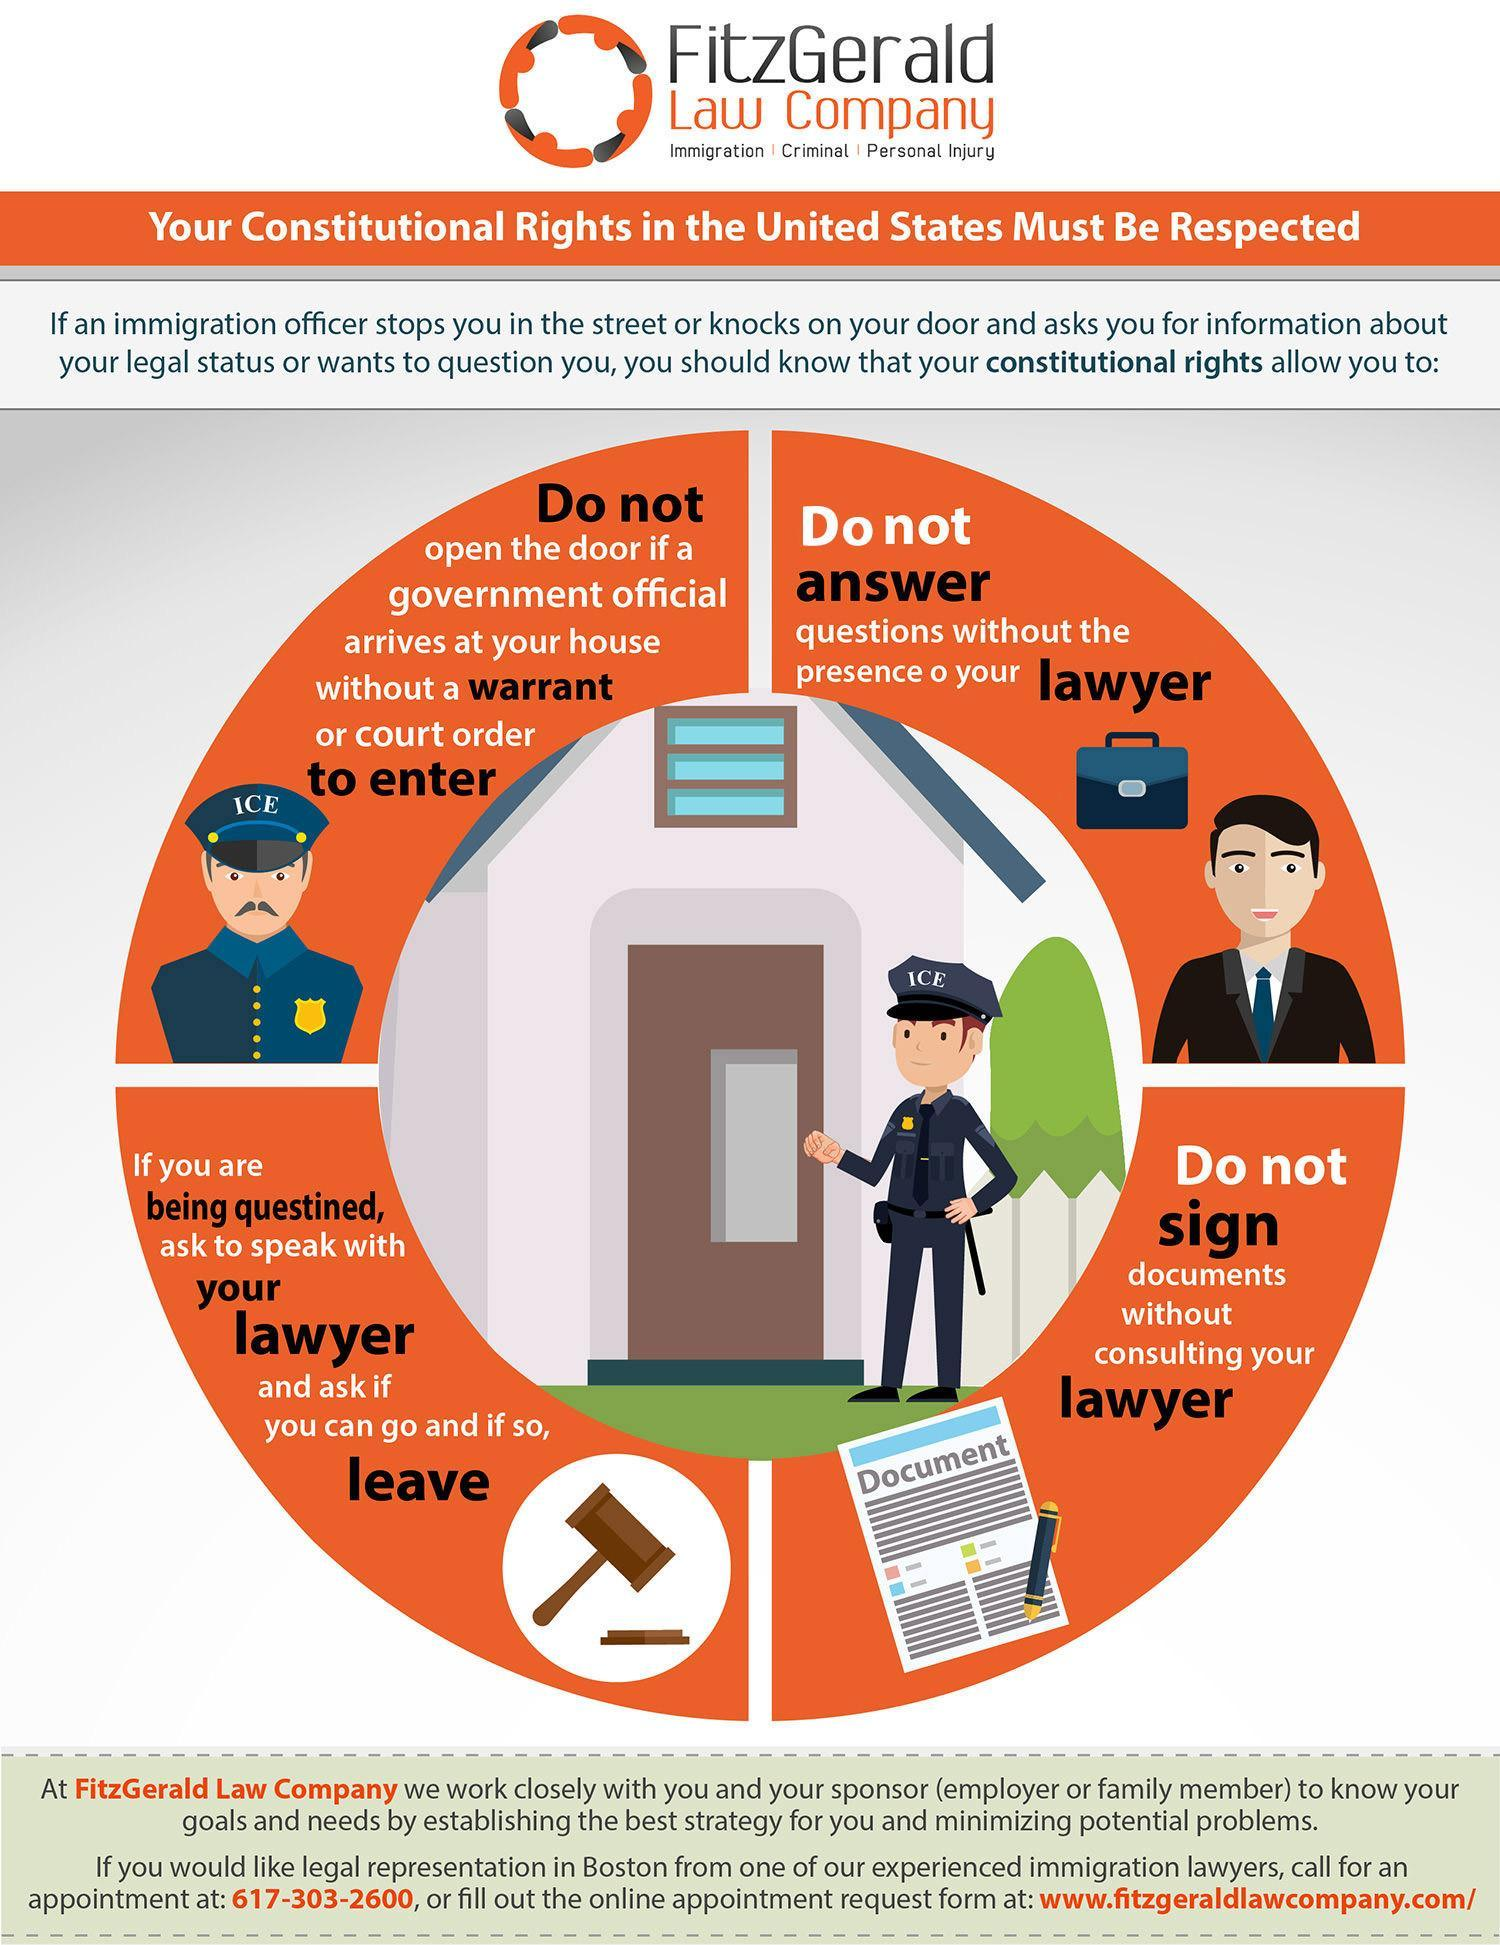What is written on the cap of the policeman?
Answer the question with a short phrase. Ice How many constitutional rights can be exercised if one is being questioned by an immigration officer? 4 